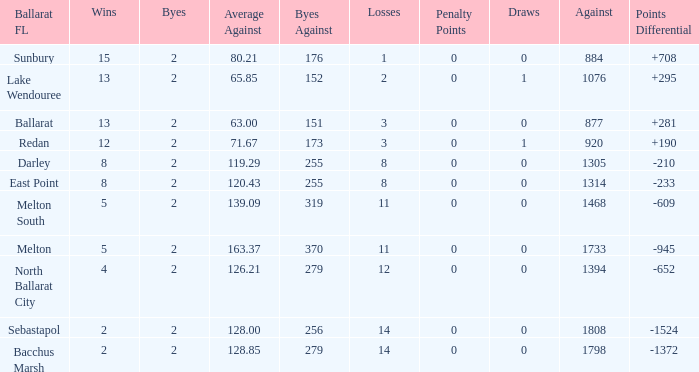How many Byes have Against of 1076 and Wins smaller than 13? None. 